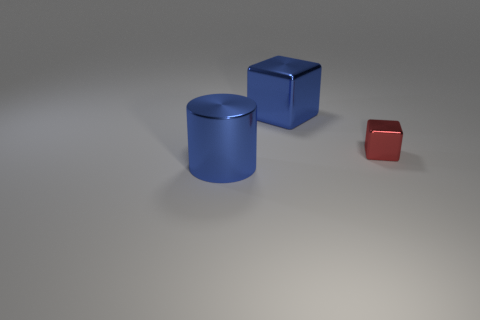Add 1 metallic cylinders. How many objects exist? 4 Subtract all cubes. How many objects are left? 1 Add 3 metallic cubes. How many metallic cubes exist? 5 Subtract 1 blue cubes. How many objects are left? 2 Subtract all metallic blocks. Subtract all yellow cylinders. How many objects are left? 1 Add 3 big shiny objects. How many big shiny objects are left? 5 